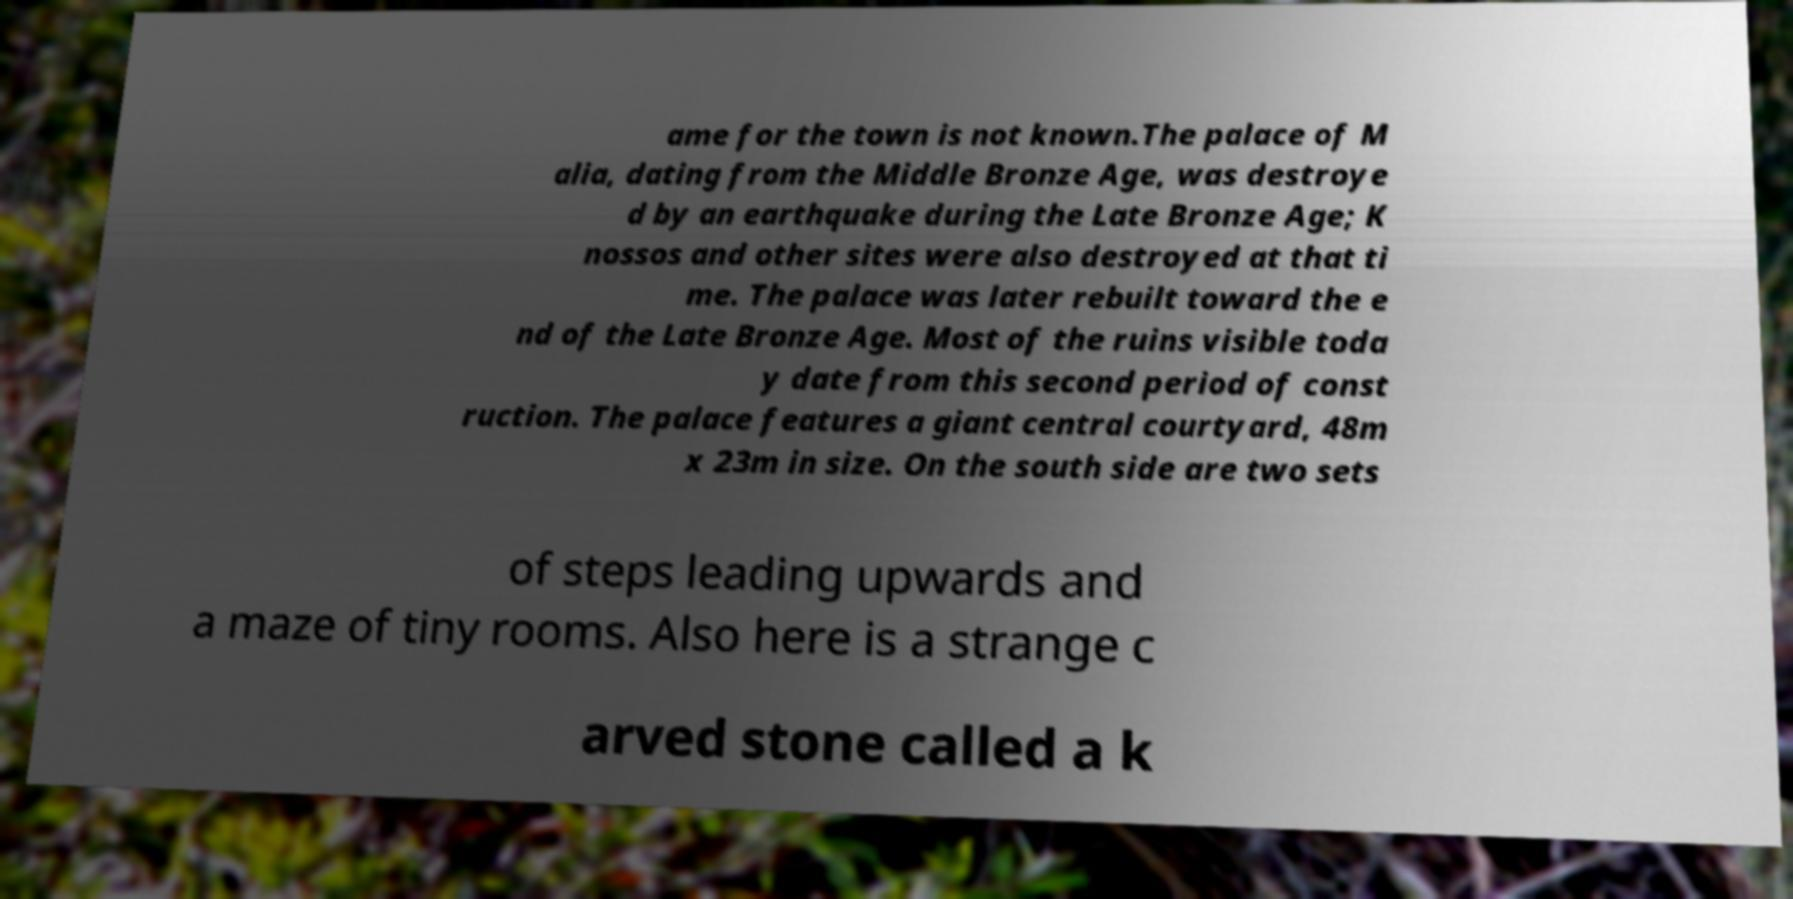Can you accurately transcribe the text from the provided image for me? ame for the town is not known.The palace of M alia, dating from the Middle Bronze Age, was destroye d by an earthquake during the Late Bronze Age; K nossos and other sites were also destroyed at that ti me. The palace was later rebuilt toward the e nd of the Late Bronze Age. Most of the ruins visible toda y date from this second period of const ruction. The palace features a giant central courtyard, 48m x 23m in size. On the south side are two sets of steps leading upwards and a maze of tiny rooms. Also here is a strange c arved stone called a k 